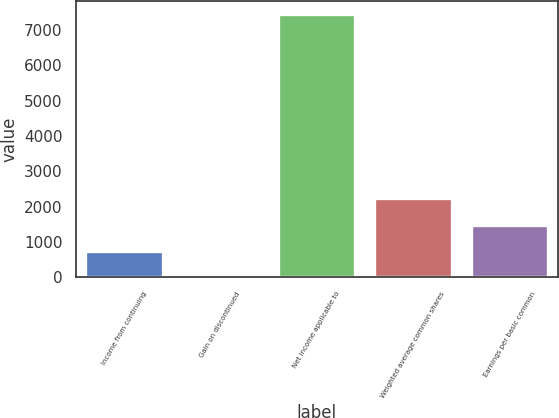Convert chart. <chart><loc_0><loc_0><loc_500><loc_500><bar_chart><fcel>Income from continuing<fcel>Gain on discontinued<fcel>Net income applicable to<fcel>Weighted average common shares<fcel>Earnings per basic common<nl><fcel>746.32<fcel>1.13<fcel>7453<fcel>2236.7<fcel>1491.51<nl></chart> 